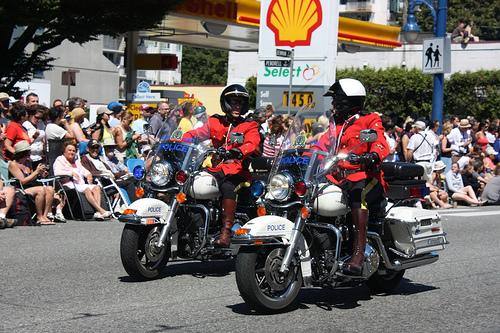What do the people seated by the road await? Please explain your reasoning. parade. There are people in a motorcade with people standing on sides of road. 